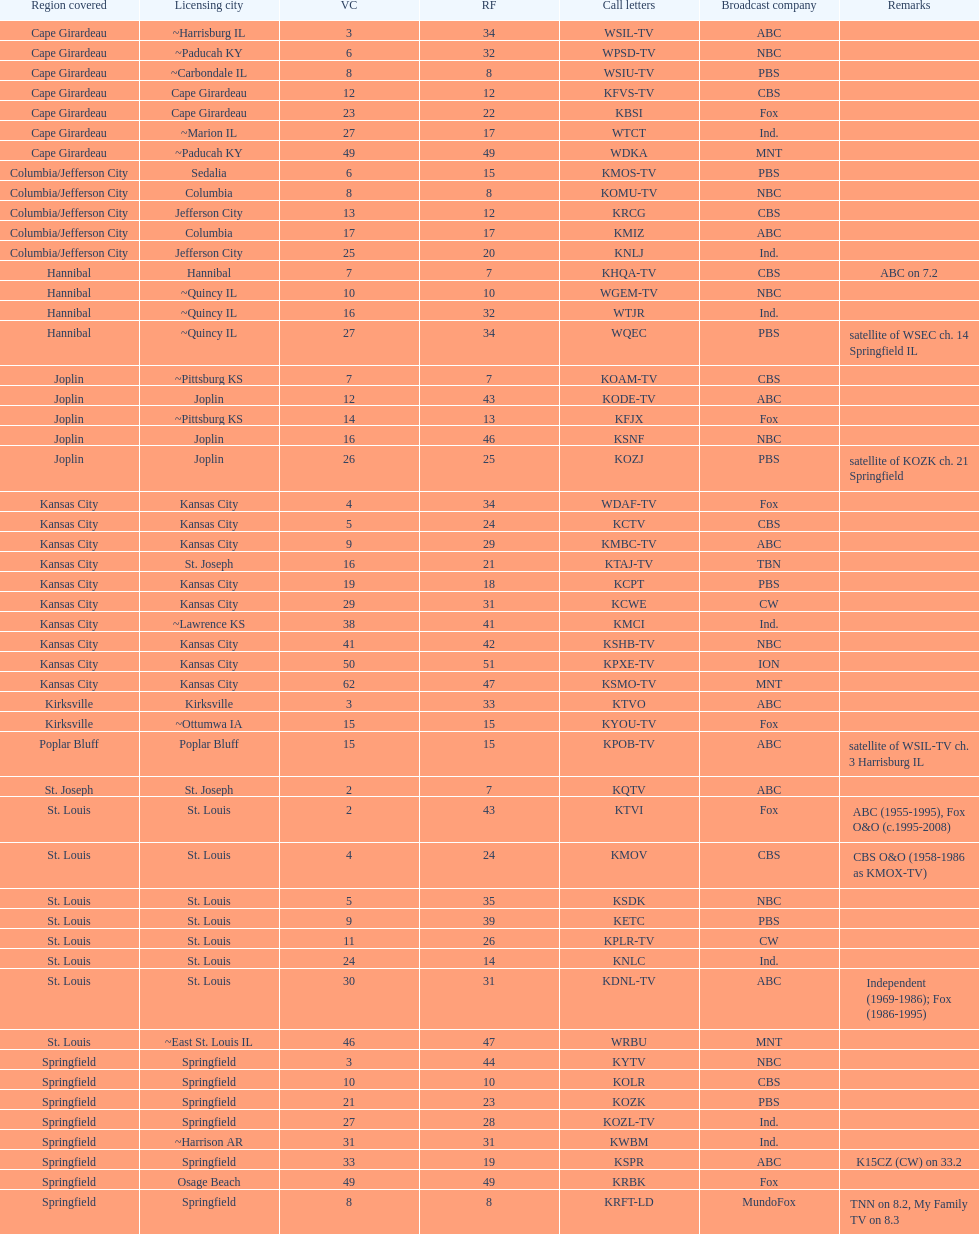How many areas have at least 5 stations? 6. 